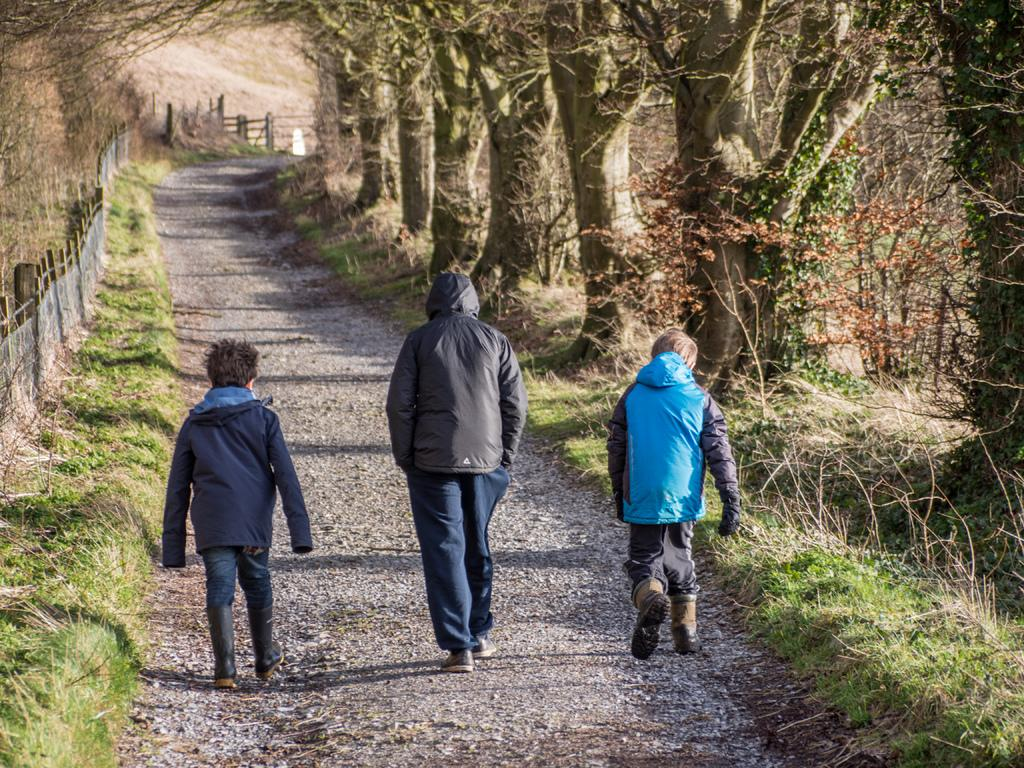How many people are walking on the road in the image? There are three persons walking on the road in the image. What type of vegetation is present in the image? There are trees in the image, and grass is on the ground. What can be seen on the left side of the image? There is fencing on the left side of the image. Can you see a snake slithering through the grass in the image? There is no snake present in the image; only the three persons walking, trees, grass, and fencing are visible. 